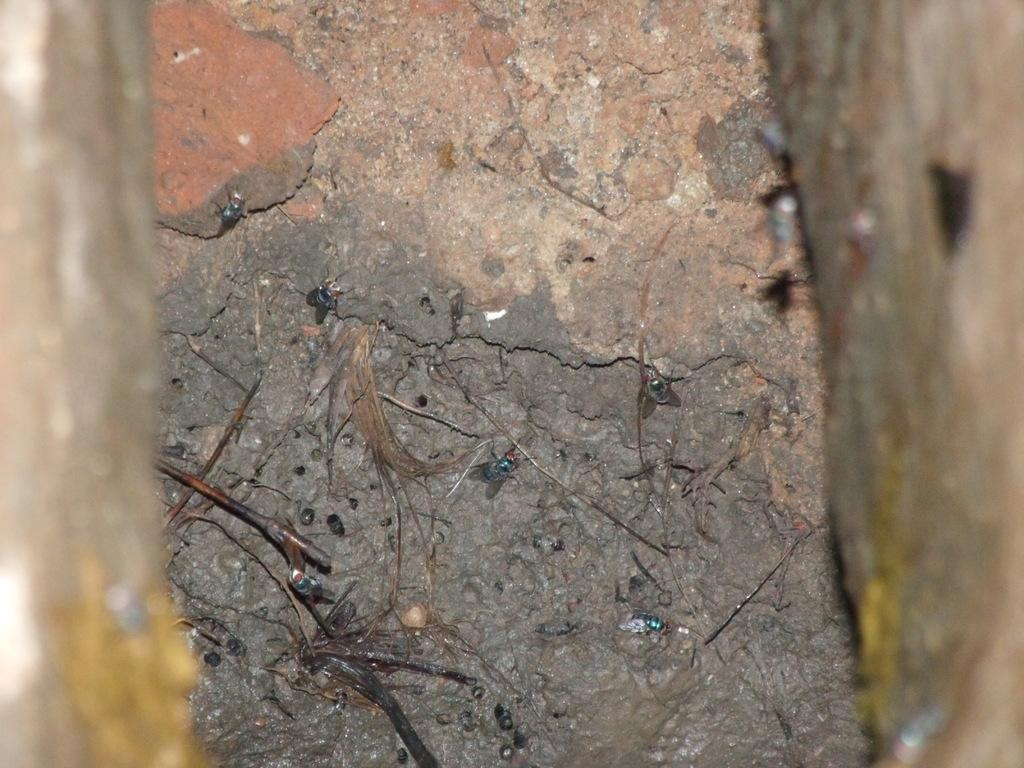What is the condition of the foreground in the image? The foreground of the image is blurred. What can be seen in the center of the image? There are twigs, house flies, soil, and a brick in the center of the image. What type of insects are present in the image? House flies are present in the image. What type of material is visible in the center of the image? Soil and a brick are visible in the center of the image. What type of bread can be seen on the bed in the image? There is no bed or bread present in the image. What topic are the house flies discussing in the image? House flies do not engage in discussions, and there is no indication of a conversation in the image. 